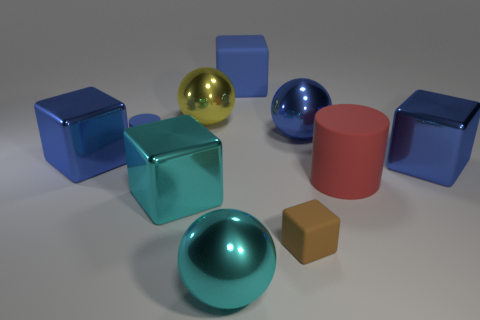Are any large blue metal cylinders visible?
Your answer should be compact. No. There is a large block right of the large rubber block that is behind the rubber object in front of the red matte thing; what is it made of?
Keep it short and to the point. Metal. There is a large red rubber object; does it have the same shape as the matte object that is on the left side of the blue matte cube?
Keep it short and to the point. Yes. What number of small rubber objects have the same shape as the big red rubber object?
Provide a short and direct response. 1. There is a tiny brown thing; what shape is it?
Ensure brevity in your answer.  Cube. There is a blue metallic cube right of the big block that is behind the small cylinder; how big is it?
Provide a succinct answer. Large. How many things are big gray cubes or cylinders?
Your answer should be compact. 2. Is the shape of the brown matte object the same as the large blue matte object?
Provide a succinct answer. Yes. Is there a yellow ball made of the same material as the cyan ball?
Your answer should be compact. Yes. Is there a cyan shiny object that is on the left side of the blue thing that is on the left side of the blue matte cylinder?
Your answer should be very brief. No. 